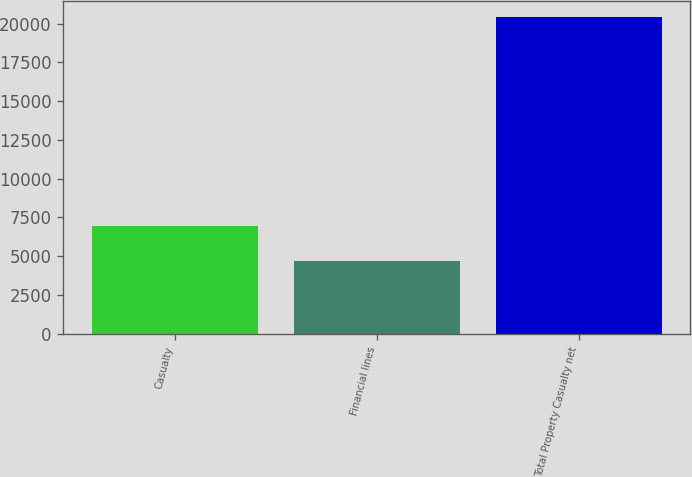<chart> <loc_0><loc_0><loc_500><loc_500><bar_chart><fcel>Casualty<fcel>Financial lines<fcel>Total Property Casualty net<nl><fcel>6957<fcel>4666<fcel>20436<nl></chart> 